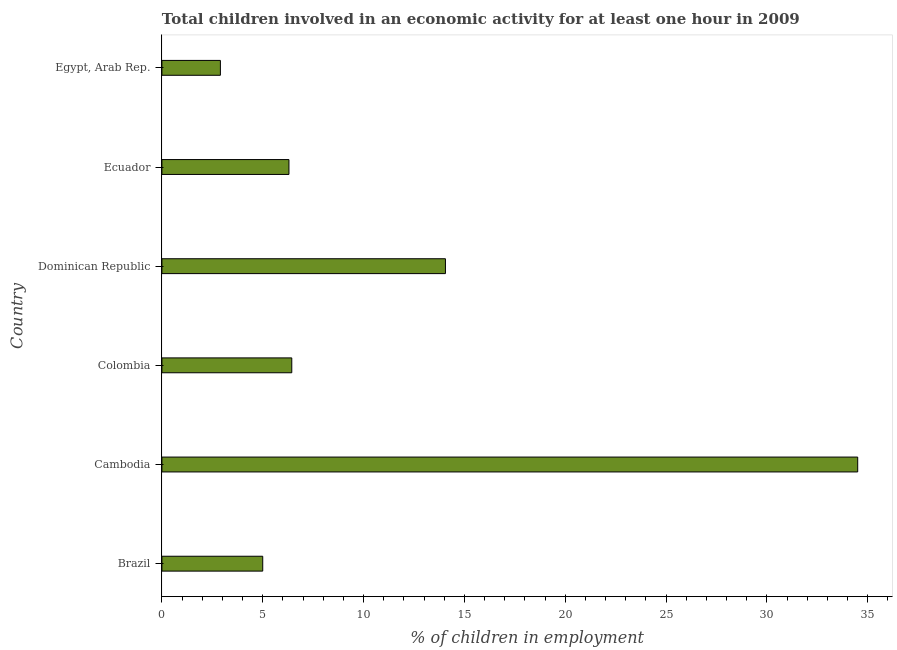Does the graph contain any zero values?
Keep it short and to the point. No. Does the graph contain grids?
Keep it short and to the point. No. What is the title of the graph?
Provide a short and direct response. Total children involved in an economic activity for at least one hour in 2009. What is the label or title of the X-axis?
Keep it short and to the point. % of children in employment. What is the label or title of the Y-axis?
Ensure brevity in your answer.  Country. What is the percentage of children in employment in Colombia?
Give a very brief answer. 6.44. Across all countries, what is the maximum percentage of children in employment?
Offer a terse response. 34.5. In which country was the percentage of children in employment maximum?
Keep it short and to the point. Cambodia. In which country was the percentage of children in employment minimum?
Keep it short and to the point. Egypt, Arab Rep. What is the sum of the percentage of children in employment?
Your response must be concise. 69.2. What is the difference between the percentage of children in employment in Cambodia and Egypt, Arab Rep.?
Provide a succinct answer. 31.6. What is the average percentage of children in employment per country?
Provide a succinct answer. 11.53. What is the median percentage of children in employment?
Ensure brevity in your answer.  6.37. What is the ratio of the percentage of children in employment in Brazil to that in Cambodia?
Provide a succinct answer. 0.14. Is the percentage of children in employment in Colombia less than that in Egypt, Arab Rep.?
Keep it short and to the point. No. Is the difference between the percentage of children in employment in Brazil and Egypt, Arab Rep. greater than the difference between any two countries?
Give a very brief answer. No. What is the difference between the highest and the second highest percentage of children in employment?
Offer a terse response. 20.44. What is the difference between the highest and the lowest percentage of children in employment?
Keep it short and to the point. 31.6. In how many countries, is the percentage of children in employment greater than the average percentage of children in employment taken over all countries?
Offer a very short reply. 2. How many bars are there?
Keep it short and to the point. 6. Are all the bars in the graph horizontal?
Your answer should be very brief. Yes. What is the difference between two consecutive major ticks on the X-axis?
Make the answer very short. 5. What is the % of children in employment of Cambodia?
Your answer should be very brief. 34.5. What is the % of children in employment in Colombia?
Offer a terse response. 6.44. What is the % of children in employment of Dominican Republic?
Your answer should be very brief. 14.06. What is the % of children in employment of Egypt, Arab Rep.?
Ensure brevity in your answer.  2.9. What is the difference between the % of children in employment in Brazil and Cambodia?
Provide a short and direct response. -29.5. What is the difference between the % of children in employment in Brazil and Colombia?
Offer a very short reply. -1.44. What is the difference between the % of children in employment in Brazil and Dominican Republic?
Your answer should be compact. -9.06. What is the difference between the % of children in employment in Brazil and Ecuador?
Offer a very short reply. -1.3. What is the difference between the % of children in employment in Cambodia and Colombia?
Keep it short and to the point. 28.06. What is the difference between the % of children in employment in Cambodia and Dominican Republic?
Provide a short and direct response. 20.44. What is the difference between the % of children in employment in Cambodia and Ecuador?
Give a very brief answer. 28.2. What is the difference between the % of children in employment in Cambodia and Egypt, Arab Rep.?
Keep it short and to the point. 31.6. What is the difference between the % of children in employment in Colombia and Dominican Republic?
Provide a short and direct response. -7.62. What is the difference between the % of children in employment in Colombia and Ecuador?
Ensure brevity in your answer.  0.14. What is the difference between the % of children in employment in Colombia and Egypt, Arab Rep.?
Make the answer very short. 3.54. What is the difference between the % of children in employment in Dominican Republic and Ecuador?
Offer a very short reply. 7.76. What is the difference between the % of children in employment in Dominican Republic and Egypt, Arab Rep.?
Offer a terse response. 11.16. What is the difference between the % of children in employment in Ecuador and Egypt, Arab Rep.?
Ensure brevity in your answer.  3.4. What is the ratio of the % of children in employment in Brazil to that in Cambodia?
Your answer should be compact. 0.14. What is the ratio of the % of children in employment in Brazil to that in Colombia?
Provide a succinct answer. 0.78. What is the ratio of the % of children in employment in Brazil to that in Dominican Republic?
Make the answer very short. 0.36. What is the ratio of the % of children in employment in Brazil to that in Ecuador?
Offer a terse response. 0.79. What is the ratio of the % of children in employment in Brazil to that in Egypt, Arab Rep.?
Your response must be concise. 1.72. What is the ratio of the % of children in employment in Cambodia to that in Colombia?
Make the answer very short. 5.36. What is the ratio of the % of children in employment in Cambodia to that in Dominican Republic?
Your answer should be compact. 2.45. What is the ratio of the % of children in employment in Cambodia to that in Ecuador?
Provide a succinct answer. 5.48. What is the ratio of the % of children in employment in Cambodia to that in Egypt, Arab Rep.?
Offer a very short reply. 11.9. What is the ratio of the % of children in employment in Colombia to that in Dominican Republic?
Keep it short and to the point. 0.46. What is the ratio of the % of children in employment in Colombia to that in Egypt, Arab Rep.?
Offer a terse response. 2.22. What is the ratio of the % of children in employment in Dominican Republic to that in Ecuador?
Provide a short and direct response. 2.23. What is the ratio of the % of children in employment in Dominican Republic to that in Egypt, Arab Rep.?
Provide a succinct answer. 4.85. What is the ratio of the % of children in employment in Ecuador to that in Egypt, Arab Rep.?
Keep it short and to the point. 2.17. 